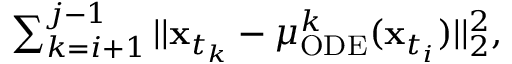Convert formula to latex. <formula><loc_0><loc_0><loc_500><loc_500>\begin{array} { r } { \sum _ { k = i + 1 } ^ { j - 1 } | | x _ { t _ { k } } - \mu _ { O D E } ^ { k } ( x _ { t _ { i } } ) | | _ { 2 } ^ { 2 } , } \end{array}</formula> 